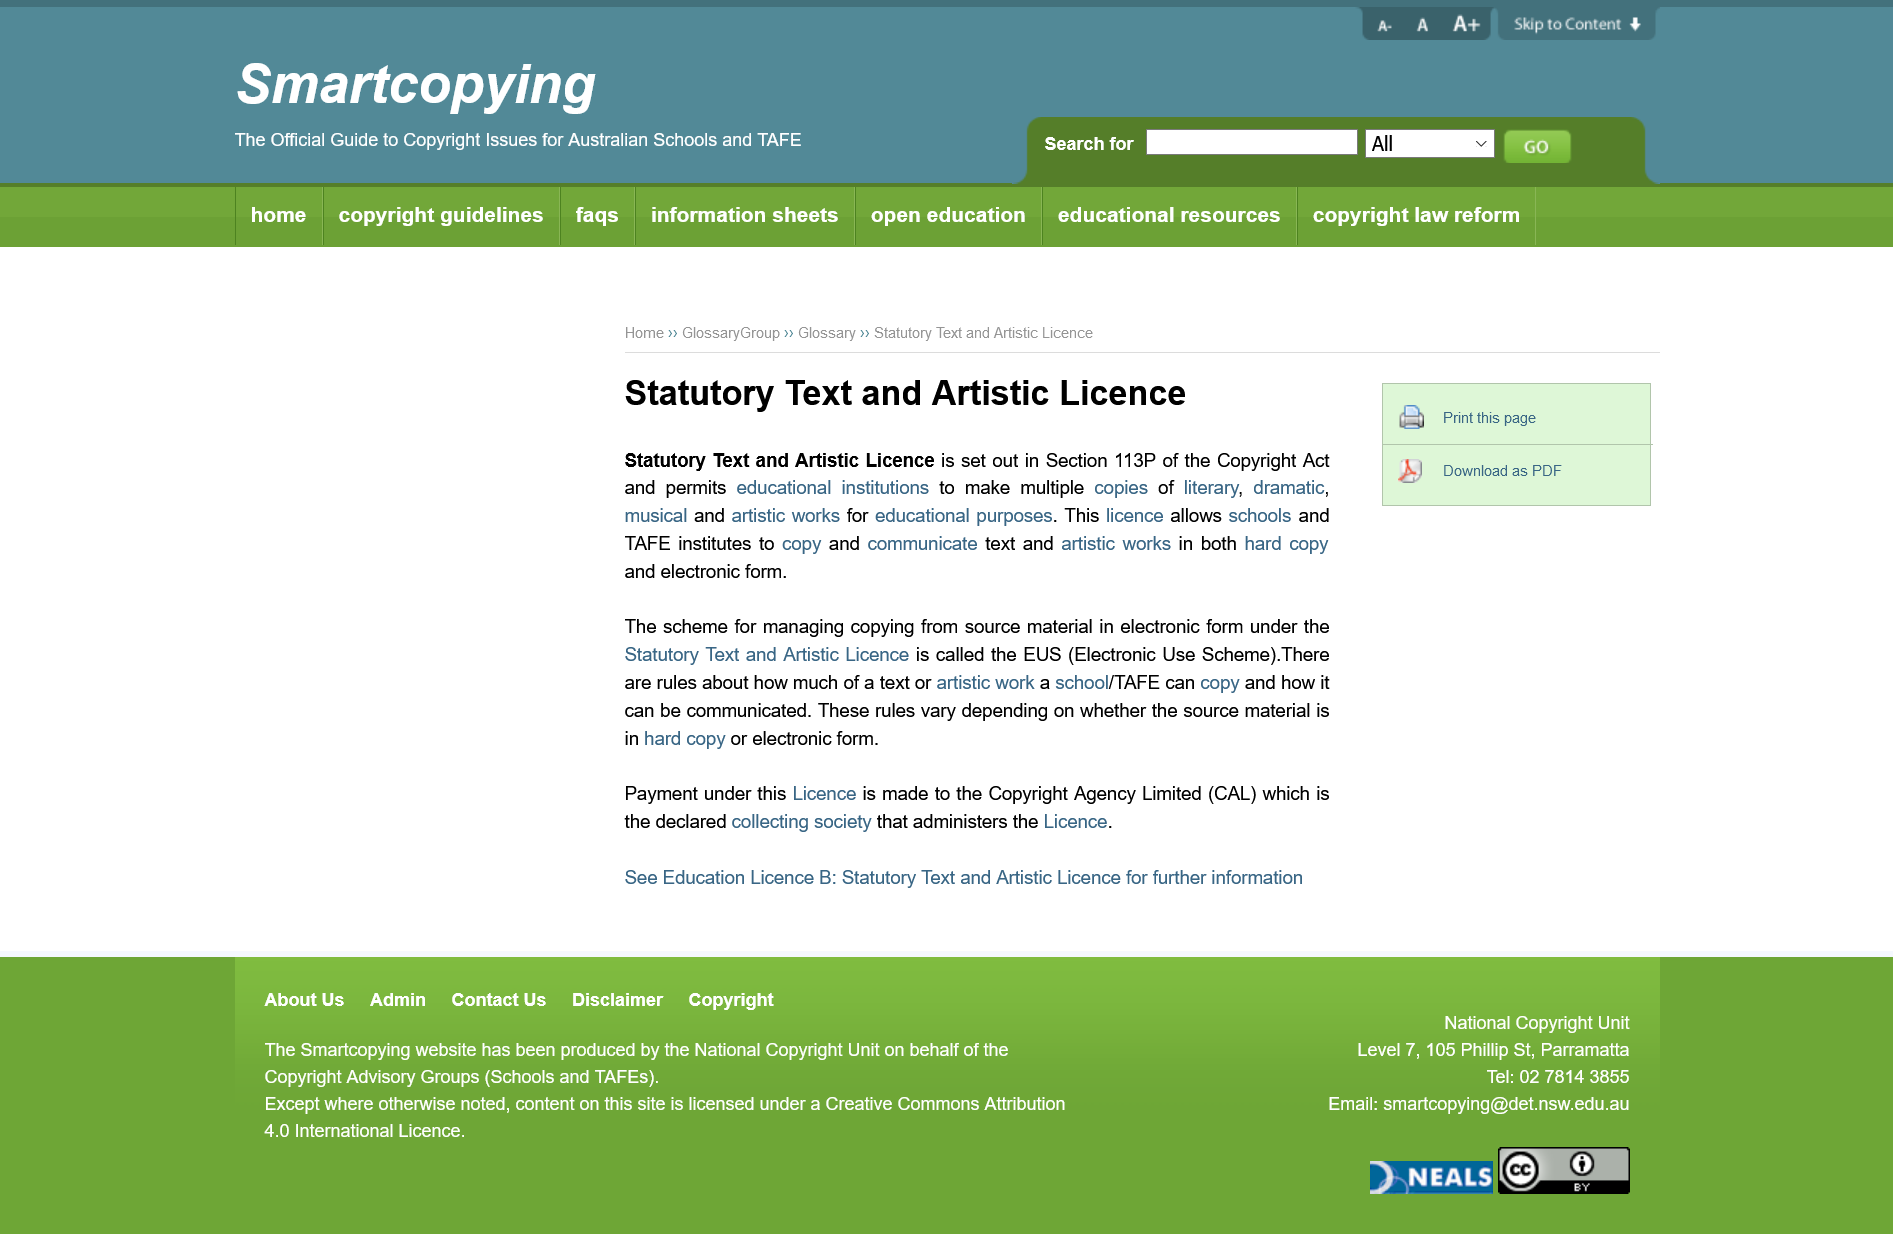Highlight a few significant elements in this photo. The license permits schools and TAFE institutes to reproduce and distribute both hard copy and electronic copies of text and artistic works. Section 113P of the Copyright Act contains the Statutory Text and Artistic Licence, which is set out in this location. The rules regarding the preservation of source material in hard copy or electronic form differ. 